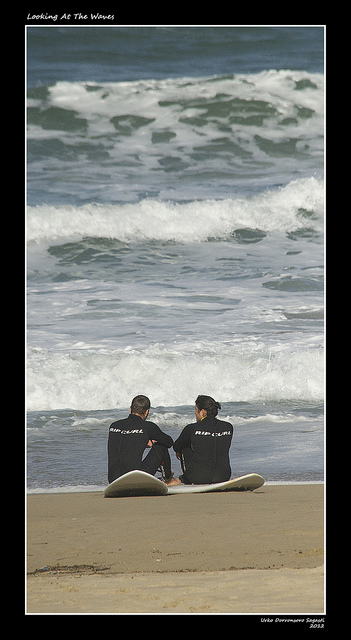How many men are there? There are two men sitting on the beach, likely surfers given their wetsuits and the surfboards beside them, enjoying the view of the rolling waves. 